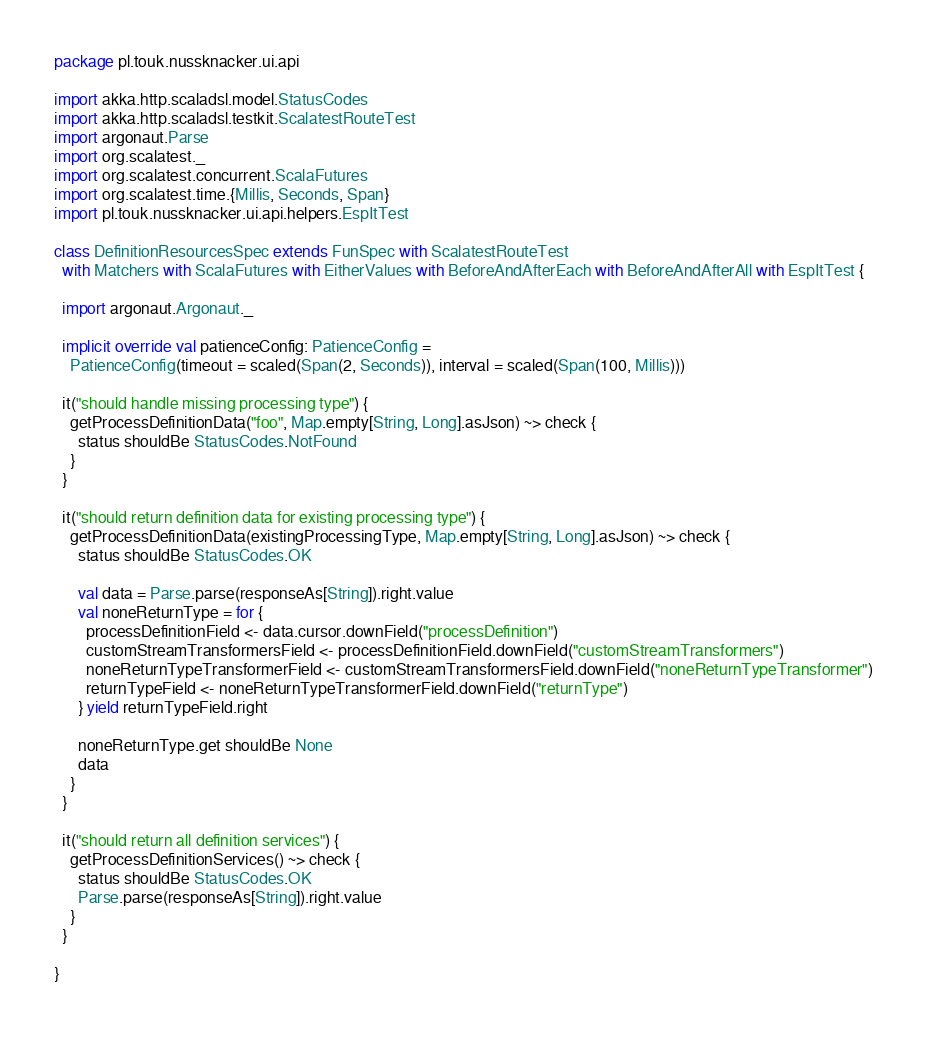Convert code to text. <code><loc_0><loc_0><loc_500><loc_500><_Scala_>package pl.touk.nussknacker.ui.api

import akka.http.scaladsl.model.StatusCodes
import akka.http.scaladsl.testkit.ScalatestRouteTest
import argonaut.Parse
import org.scalatest._
import org.scalatest.concurrent.ScalaFutures
import org.scalatest.time.{Millis, Seconds, Span}
import pl.touk.nussknacker.ui.api.helpers.EspItTest

class DefinitionResourcesSpec extends FunSpec with ScalatestRouteTest
  with Matchers with ScalaFutures with EitherValues with BeforeAndAfterEach with BeforeAndAfterAll with EspItTest {

  import argonaut.Argonaut._

  implicit override val patienceConfig: PatienceConfig =
    PatienceConfig(timeout = scaled(Span(2, Seconds)), interval = scaled(Span(100, Millis)))

  it("should handle missing processing type") {
    getProcessDefinitionData("foo", Map.empty[String, Long].asJson) ~> check {
      status shouldBe StatusCodes.NotFound
    }
  }

  it("should return definition data for existing processing type") {
    getProcessDefinitionData(existingProcessingType, Map.empty[String, Long].asJson) ~> check {
      status shouldBe StatusCodes.OK

      val data = Parse.parse(responseAs[String]).right.value
      val noneReturnType = for {
        processDefinitionField <- data.cursor.downField("processDefinition")
        customStreamTransformersField <- processDefinitionField.downField("customStreamTransformers")
        noneReturnTypeTransformerField <- customStreamTransformersField.downField("noneReturnTypeTransformer")
        returnTypeField <- noneReturnTypeTransformerField.downField("returnType")
      } yield returnTypeField.right

      noneReturnType.get shouldBe None
      data
    }
  }

  it("should return all definition services") {
    getProcessDefinitionServices() ~> check {
      status shouldBe StatusCodes.OK
      Parse.parse(responseAs[String]).right.value
    }
  }

}
</code> 